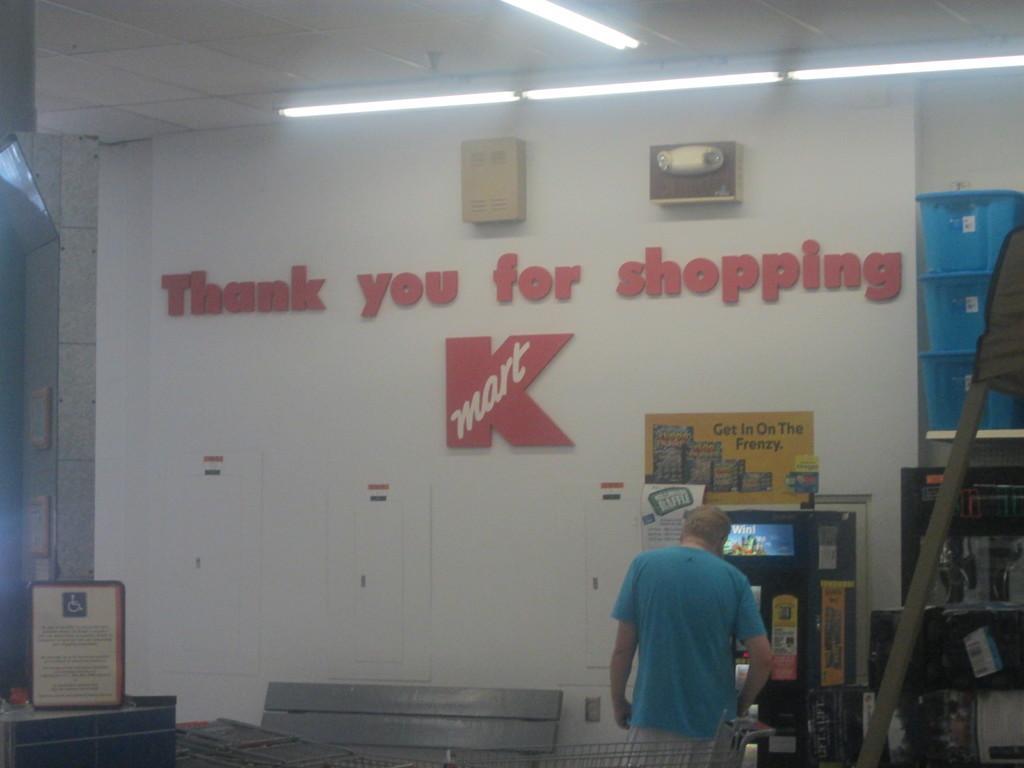In one or two sentences, can you explain what this image depicts? In this image we can see a person, cart, boards, vending machine, baskets, lights, ceiling, wall, posters, and other objects. 